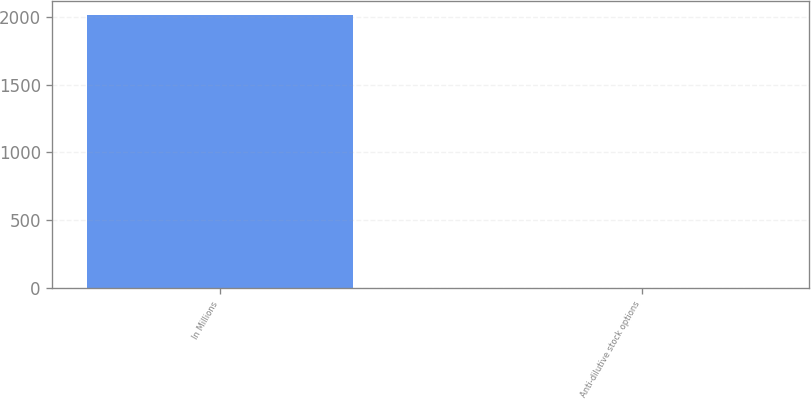<chart> <loc_0><loc_0><loc_500><loc_500><bar_chart><fcel>In Millions<fcel>Anti-dilutive stock options<nl><fcel>2014<fcel>1.7<nl></chart> 